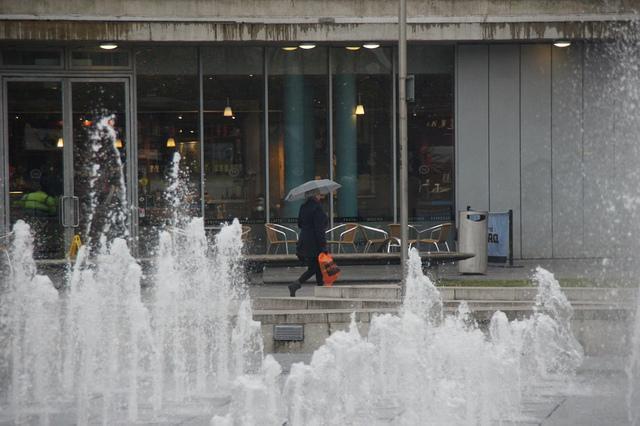How many skis are level against the snow?
Give a very brief answer. 0. 